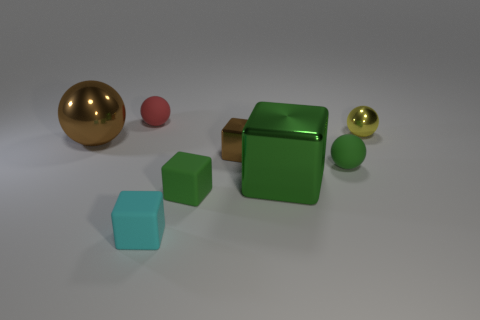Add 1 small red spheres. How many objects exist? 9 Add 8 gray metal cylinders. How many gray metal cylinders exist? 8 Subtract 0 purple cylinders. How many objects are left? 8 Subtract all tiny purple metallic spheres. Subtract all cyan matte blocks. How many objects are left? 7 Add 5 red matte things. How many red matte things are left? 6 